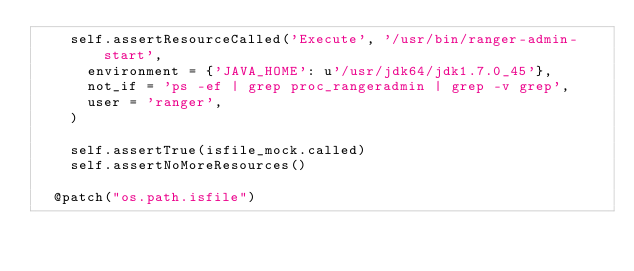Convert code to text. <code><loc_0><loc_0><loc_500><loc_500><_Python_>    self.assertResourceCalled('Execute', '/usr/bin/ranger-admin-start',
      environment = {'JAVA_HOME': u'/usr/jdk64/jdk1.7.0_45'},
      not_if = 'ps -ef | grep proc_rangeradmin | grep -v grep',
      user = 'ranger',
    )

    self.assertTrue(isfile_mock.called)
    self.assertNoMoreResources()

  @patch("os.path.isfile")</code> 